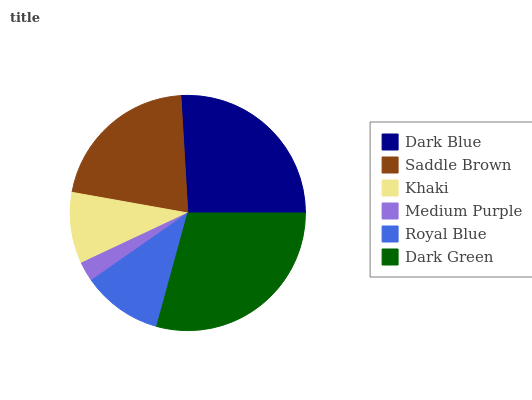Is Medium Purple the minimum?
Answer yes or no. Yes. Is Dark Green the maximum?
Answer yes or no. Yes. Is Saddle Brown the minimum?
Answer yes or no. No. Is Saddle Brown the maximum?
Answer yes or no. No. Is Dark Blue greater than Saddle Brown?
Answer yes or no. Yes. Is Saddle Brown less than Dark Blue?
Answer yes or no. Yes. Is Saddle Brown greater than Dark Blue?
Answer yes or no. No. Is Dark Blue less than Saddle Brown?
Answer yes or no. No. Is Saddle Brown the high median?
Answer yes or no. Yes. Is Royal Blue the low median?
Answer yes or no. Yes. Is Dark Green the high median?
Answer yes or no. No. Is Medium Purple the low median?
Answer yes or no. No. 